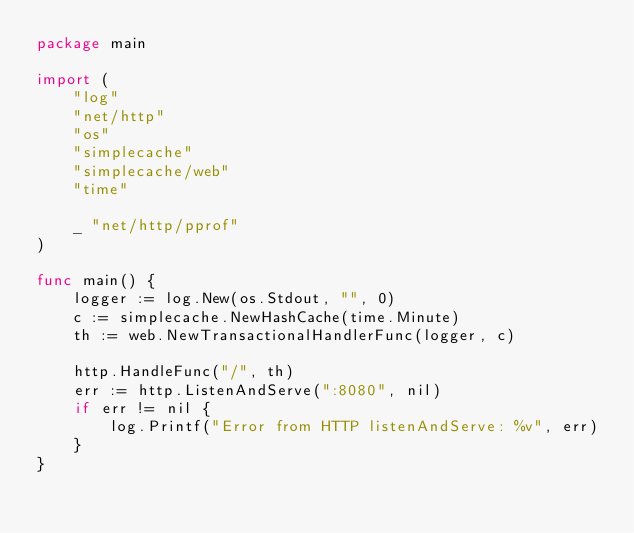<code> <loc_0><loc_0><loc_500><loc_500><_Go_>package main

import (
	"log"
	"net/http"
	"os"
	"simplecache"
	"simplecache/web"
	"time"

	_ "net/http/pprof"
)

func main() {
	logger := log.New(os.Stdout, "", 0)
	c := simplecache.NewHashCache(time.Minute)
	th := web.NewTransactionalHandlerFunc(logger, c)

	http.HandleFunc("/", th)
	err := http.ListenAndServe(":8080", nil)
	if err != nil {
		log.Printf("Error from HTTP listenAndServe: %v", err)
	}
}
</code> 